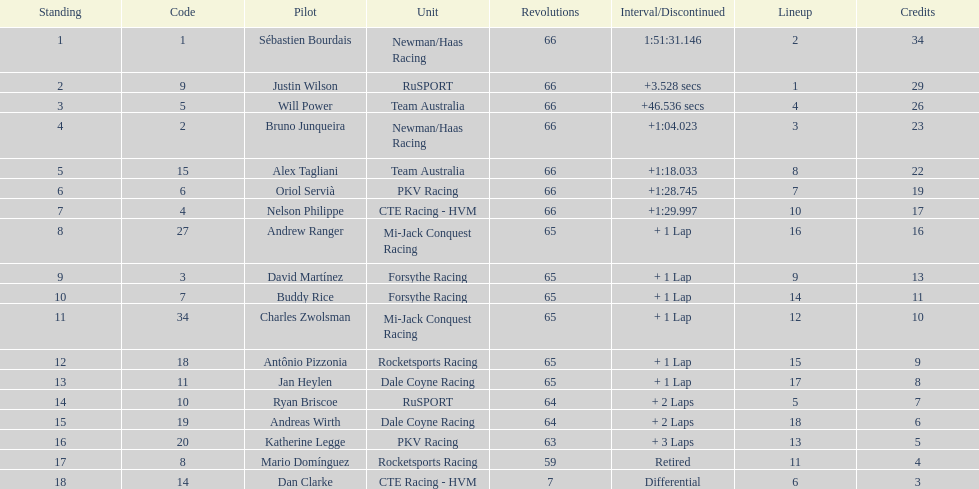At the 2006 gran premio telmex, who scored the highest number of points? Sébastien Bourdais. 